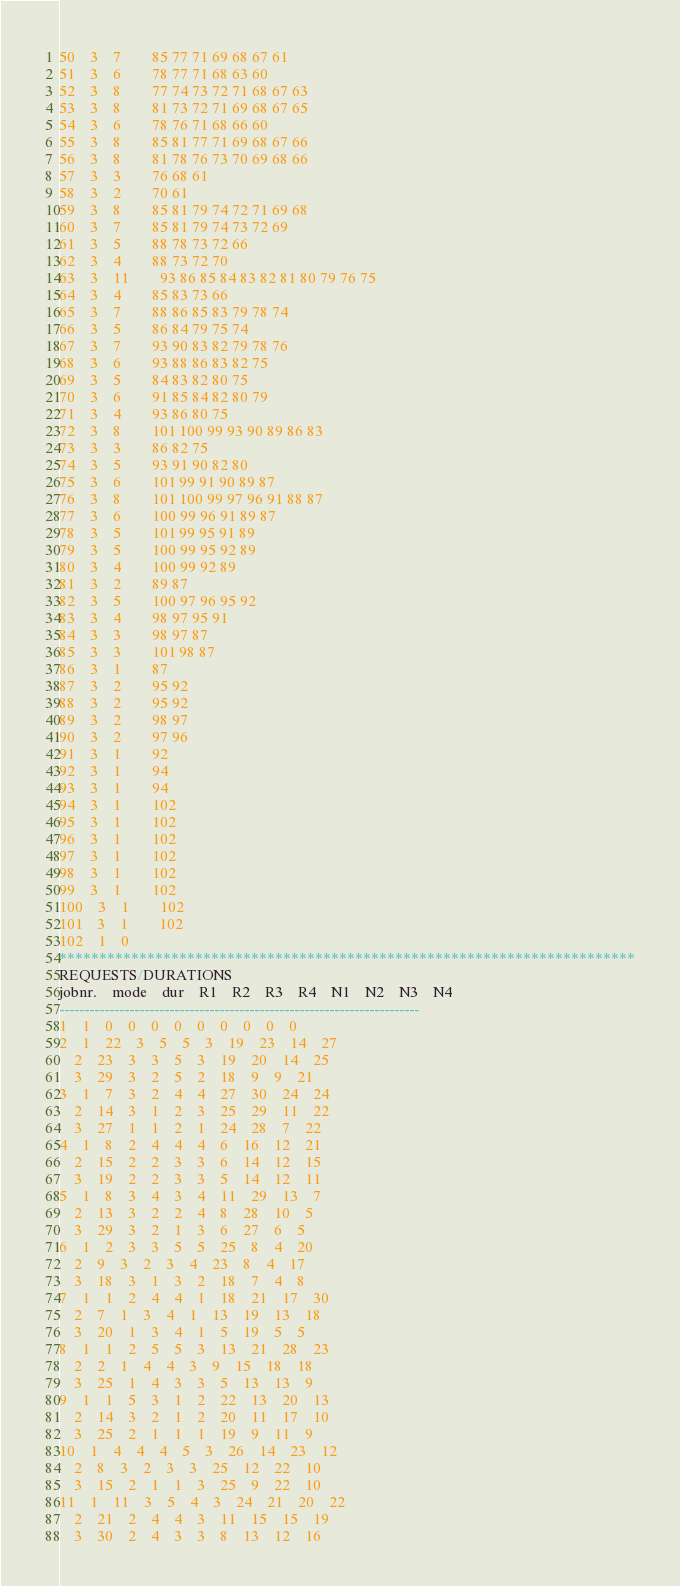<code> <loc_0><loc_0><loc_500><loc_500><_ObjectiveC_>50	3	7		85 77 71 69 68 67 61 
51	3	6		78 77 71 68 63 60 
52	3	8		77 74 73 72 71 68 67 63 
53	3	8		81 73 72 71 69 68 67 65 
54	3	6		78 76 71 68 66 60 
55	3	8		85 81 77 71 69 68 67 66 
56	3	8		81 78 76 73 70 69 68 66 
57	3	3		76 68 61 
58	3	2		70 61 
59	3	8		85 81 79 74 72 71 69 68 
60	3	7		85 81 79 74 73 72 69 
61	3	5		88 78 73 72 66 
62	3	4		88 73 72 70 
63	3	11		93 86 85 84 83 82 81 80 79 76 75 
64	3	4		85 83 73 66 
65	3	7		88 86 85 83 79 78 74 
66	3	5		86 84 79 75 74 
67	3	7		93 90 83 82 79 78 76 
68	3	6		93 88 86 83 82 75 
69	3	5		84 83 82 80 75 
70	3	6		91 85 84 82 80 79 
71	3	4		93 86 80 75 
72	3	8		101 100 99 93 90 89 86 83 
73	3	3		86 82 75 
74	3	5		93 91 90 82 80 
75	3	6		101 99 91 90 89 87 
76	3	8		101 100 99 97 96 91 88 87 
77	3	6		100 99 96 91 89 87 
78	3	5		101 99 95 91 89 
79	3	5		100 99 95 92 89 
80	3	4		100 99 92 89 
81	3	2		89 87 
82	3	5		100 97 96 95 92 
83	3	4		98 97 95 91 
84	3	3		98 97 87 
85	3	3		101 98 87 
86	3	1		87 
87	3	2		95 92 
88	3	2		95 92 
89	3	2		98 97 
90	3	2		97 96 
91	3	1		92 
92	3	1		94 
93	3	1		94 
94	3	1		102 
95	3	1		102 
96	3	1		102 
97	3	1		102 
98	3	1		102 
99	3	1		102 
100	3	1		102 
101	3	1		102 
102	1	0		
************************************************************************
REQUESTS/DURATIONS
jobnr.	mode	dur	R1	R2	R3	R4	N1	N2	N3	N4	
------------------------------------------------------------------------
1	1	0	0	0	0	0	0	0	0	0	
2	1	22	3	5	5	3	19	23	14	27	
	2	23	3	3	5	3	19	20	14	25	
	3	29	3	2	5	2	18	9	9	21	
3	1	7	3	2	4	4	27	30	24	24	
	2	14	3	1	2	3	25	29	11	22	
	3	27	1	1	2	1	24	28	7	22	
4	1	8	2	4	4	4	6	16	12	21	
	2	15	2	2	3	3	6	14	12	15	
	3	19	2	2	3	3	5	14	12	11	
5	1	8	3	4	3	4	11	29	13	7	
	2	13	3	2	2	4	8	28	10	5	
	3	29	3	2	1	3	6	27	6	5	
6	1	2	3	3	5	5	25	8	4	20	
	2	9	3	2	3	4	23	8	4	17	
	3	18	3	1	3	2	18	7	4	8	
7	1	1	2	4	4	1	18	21	17	30	
	2	7	1	3	4	1	13	19	13	18	
	3	20	1	3	4	1	5	19	5	5	
8	1	1	2	5	5	3	13	21	28	23	
	2	2	1	4	4	3	9	15	18	18	
	3	25	1	4	3	3	5	13	13	9	
9	1	1	5	3	1	2	22	13	20	13	
	2	14	3	2	1	2	20	11	17	10	
	3	25	2	1	1	1	19	9	11	9	
10	1	4	4	4	5	3	26	14	23	12	
	2	8	3	2	3	3	25	12	22	10	
	3	15	2	1	1	3	25	9	22	10	
11	1	11	3	5	4	3	24	21	20	22	
	2	21	2	4	4	3	11	15	15	19	
	3	30	2	4	3	3	8	13	12	16	</code> 